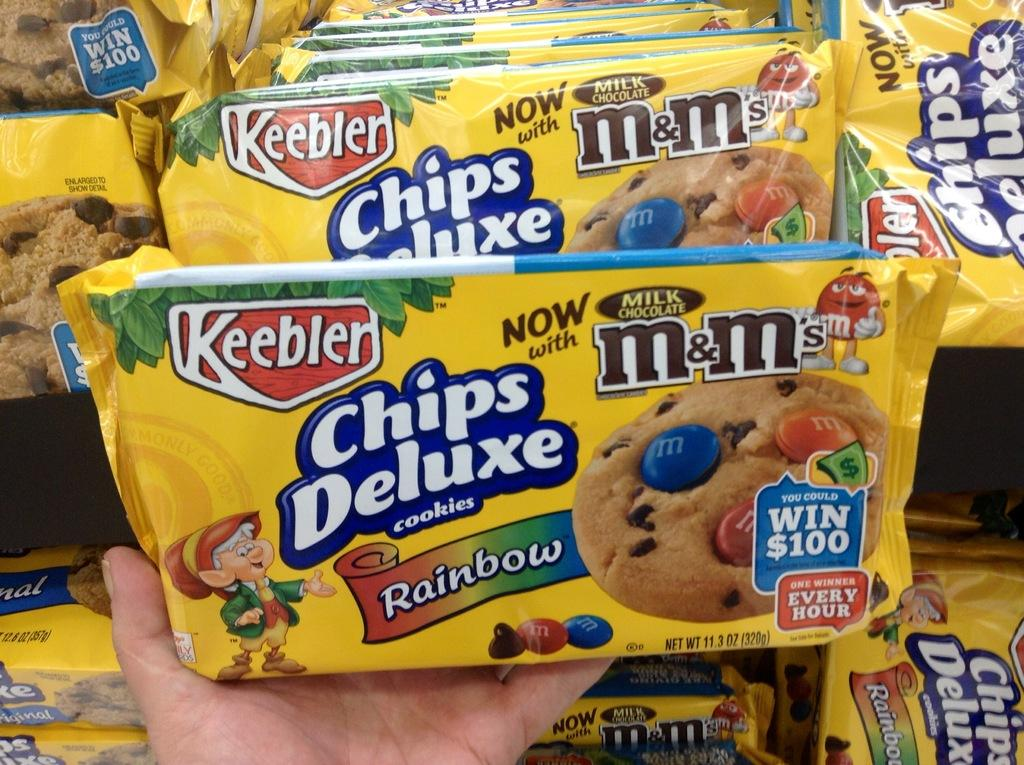What is the person holding in their hand in the image? There is a biscuit packet in a person's hand. Where can more biscuit packets be found in the image? There are additional biscuit packets on racks. What type of prison is visible in the background of the image? There is no prison visible in the image; it only shows biscuit packets in a person's hand and on racks. 